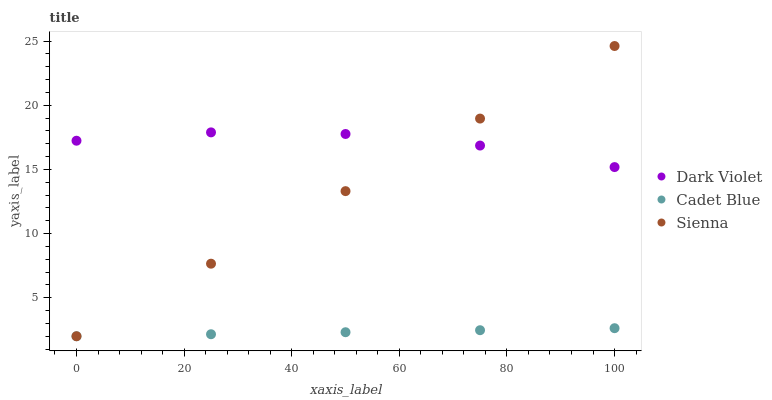Does Cadet Blue have the minimum area under the curve?
Answer yes or no. Yes. Does Dark Violet have the maximum area under the curve?
Answer yes or no. Yes. Does Dark Violet have the minimum area under the curve?
Answer yes or no. No. Does Cadet Blue have the maximum area under the curve?
Answer yes or no. No. Is Cadet Blue the smoothest?
Answer yes or no. Yes. Is Dark Violet the roughest?
Answer yes or no. Yes. Is Dark Violet the smoothest?
Answer yes or no. No. Is Cadet Blue the roughest?
Answer yes or no. No. Does Sienna have the lowest value?
Answer yes or no. Yes. Does Dark Violet have the lowest value?
Answer yes or no. No. Does Sienna have the highest value?
Answer yes or no. Yes. Does Dark Violet have the highest value?
Answer yes or no. No. Is Cadet Blue less than Dark Violet?
Answer yes or no. Yes. Is Dark Violet greater than Cadet Blue?
Answer yes or no. Yes. Does Sienna intersect Cadet Blue?
Answer yes or no. Yes. Is Sienna less than Cadet Blue?
Answer yes or no. No. Is Sienna greater than Cadet Blue?
Answer yes or no. No. Does Cadet Blue intersect Dark Violet?
Answer yes or no. No. 